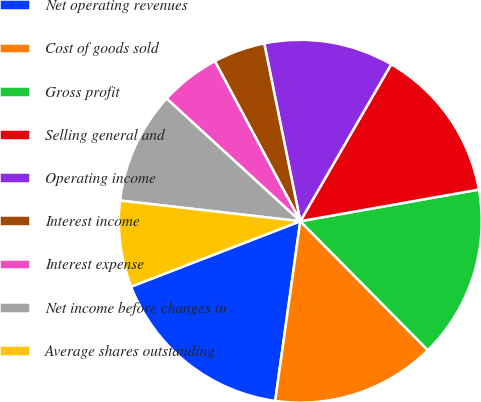Convert chart to OTSL. <chart><loc_0><loc_0><loc_500><loc_500><pie_chart><fcel>Net operating revenues<fcel>Cost of goods sold<fcel>Gross profit<fcel>Selling general and<fcel>Operating income<fcel>Interest income<fcel>Interest expense<fcel>Net income before changes in<fcel>Average shares outstanding<nl><fcel>16.92%<fcel>14.62%<fcel>15.38%<fcel>13.85%<fcel>11.54%<fcel>4.62%<fcel>5.38%<fcel>10.0%<fcel>7.69%<nl></chart> 